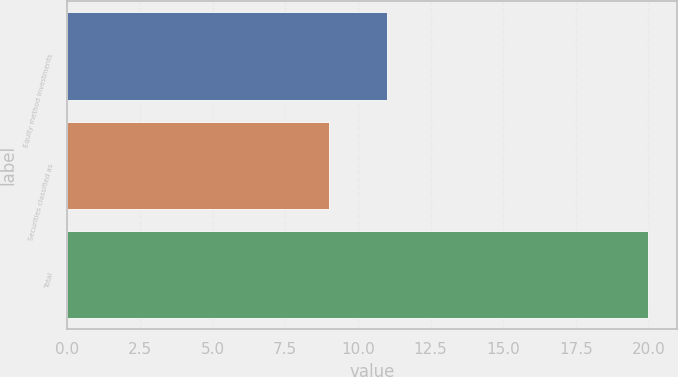<chart> <loc_0><loc_0><loc_500><loc_500><bar_chart><fcel>Equity method investments<fcel>Securities classified as<fcel>Total<nl><fcel>11<fcel>9<fcel>20<nl></chart> 